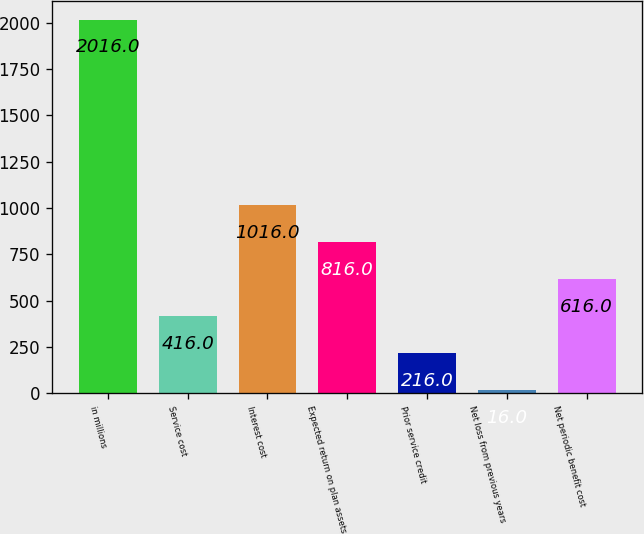Convert chart to OTSL. <chart><loc_0><loc_0><loc_500><loc_500><bar_chart><fcel>in millions<fcel>Service cost<fcel>Interest cost<fcel>Expected return on plan assets<fcel>Prior service credit<fcel>Net loss from previous years<fcel>Net periodic benefit cost<nl><fcel>2016<fcel>416<fcel>1016<fcel>816<fcel>216<fcel>16<fcel>616<nl></chart> 